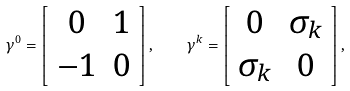Convert formula to latex. <formula><loc_0><loc_0><loc_500><loc_500>\gamma ^ { 0 } = \left [ \begin{array} { c c } 0 & 1 \\ - 1 & 0 \end{array} \right ] , \quad \gamma ^ { k } = \left [ \begin{array} { c c } 0 & \sigma _ { k } \\ \sigma _ { k } & 0 \end{array} \right ] ,</formula> 